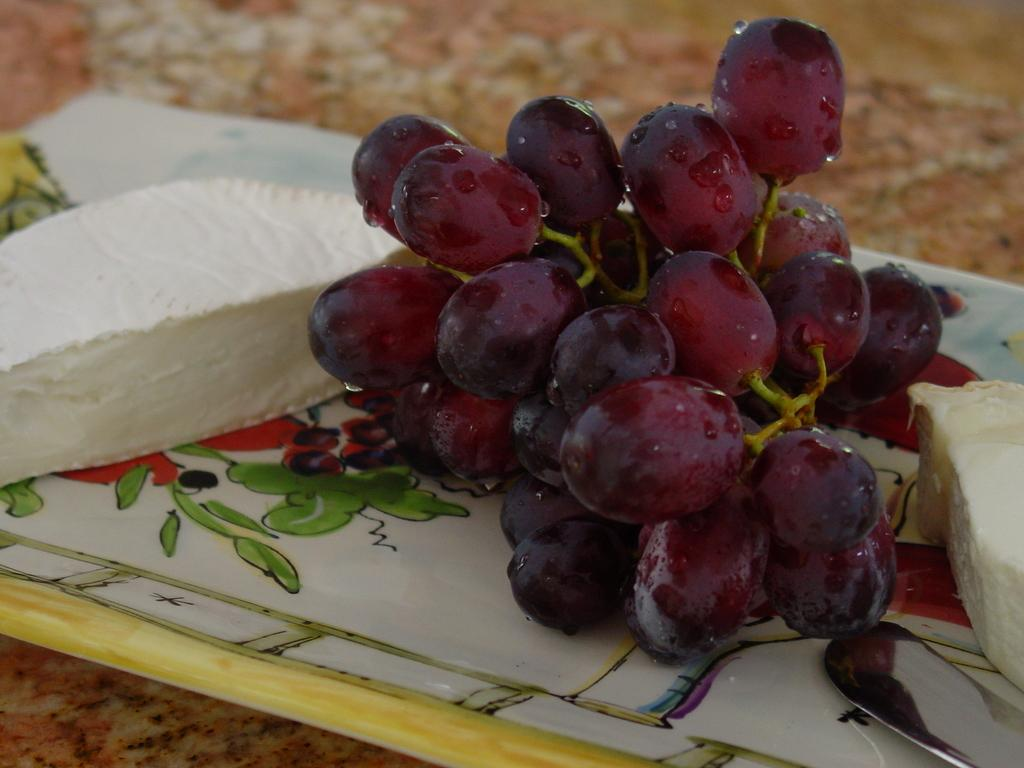What is the main subject in the center of the image? There is cheese in the center of the image. What other food item can be seen in the image? There are grapes in the image. How are the grapes arranged? The grapes are placed on a tray. What piece of furniture is visible at the bottom of the image? There is a table at the bottom of the image. What type of zinc is present in the image? There is no zinc present in the image. How is the waste being disposed of in the image? There is no waste disposal visible in the image. 